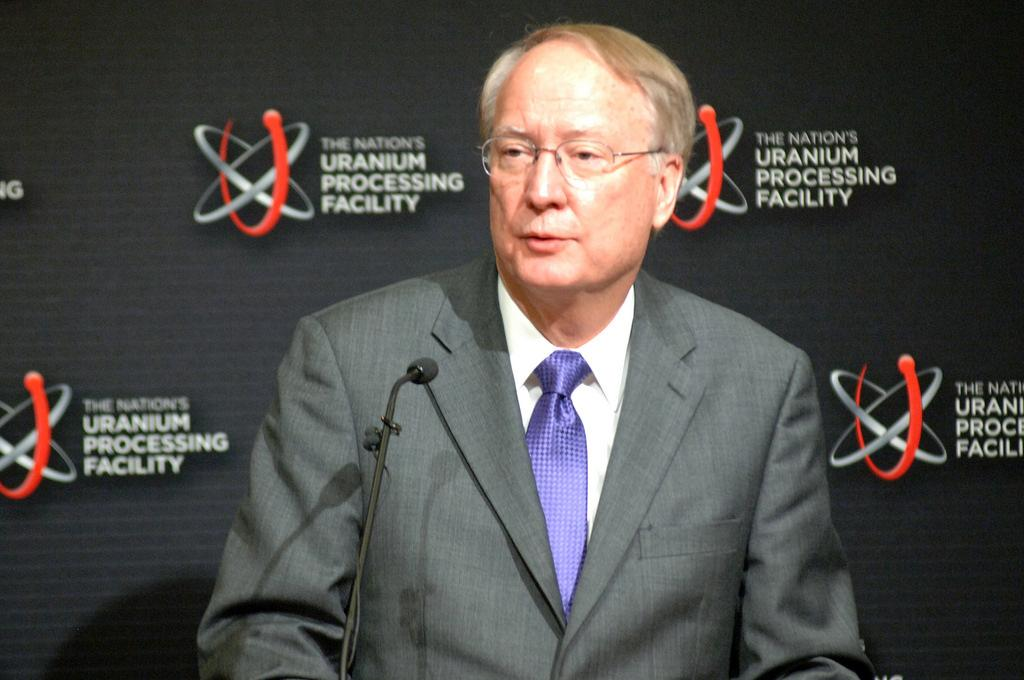What is the main subject in the foreground of the image? There is a person in the foreground of the image. What is the person doing in the image? The person is in front of a microphone, which suggests they may be speaking or performing. What is the person wearing in the image? The person is wearing a suit. What can be seen in the background of the image? There is a curtain and a logo in the background of the image. What type of location might the image have been taken in? The image may have been taken in a hall, given the presence of a microphone and a stage-like setting. How many cubs are visible in the image? There are no cubs present in the image. What type of currency is being used in the image? There is no reference to currency in the image. 